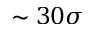Convert formula to latex. <formula><loc_0><loc_0><loc_500><loc_500>\sim 3 0 \sigma</formula> 